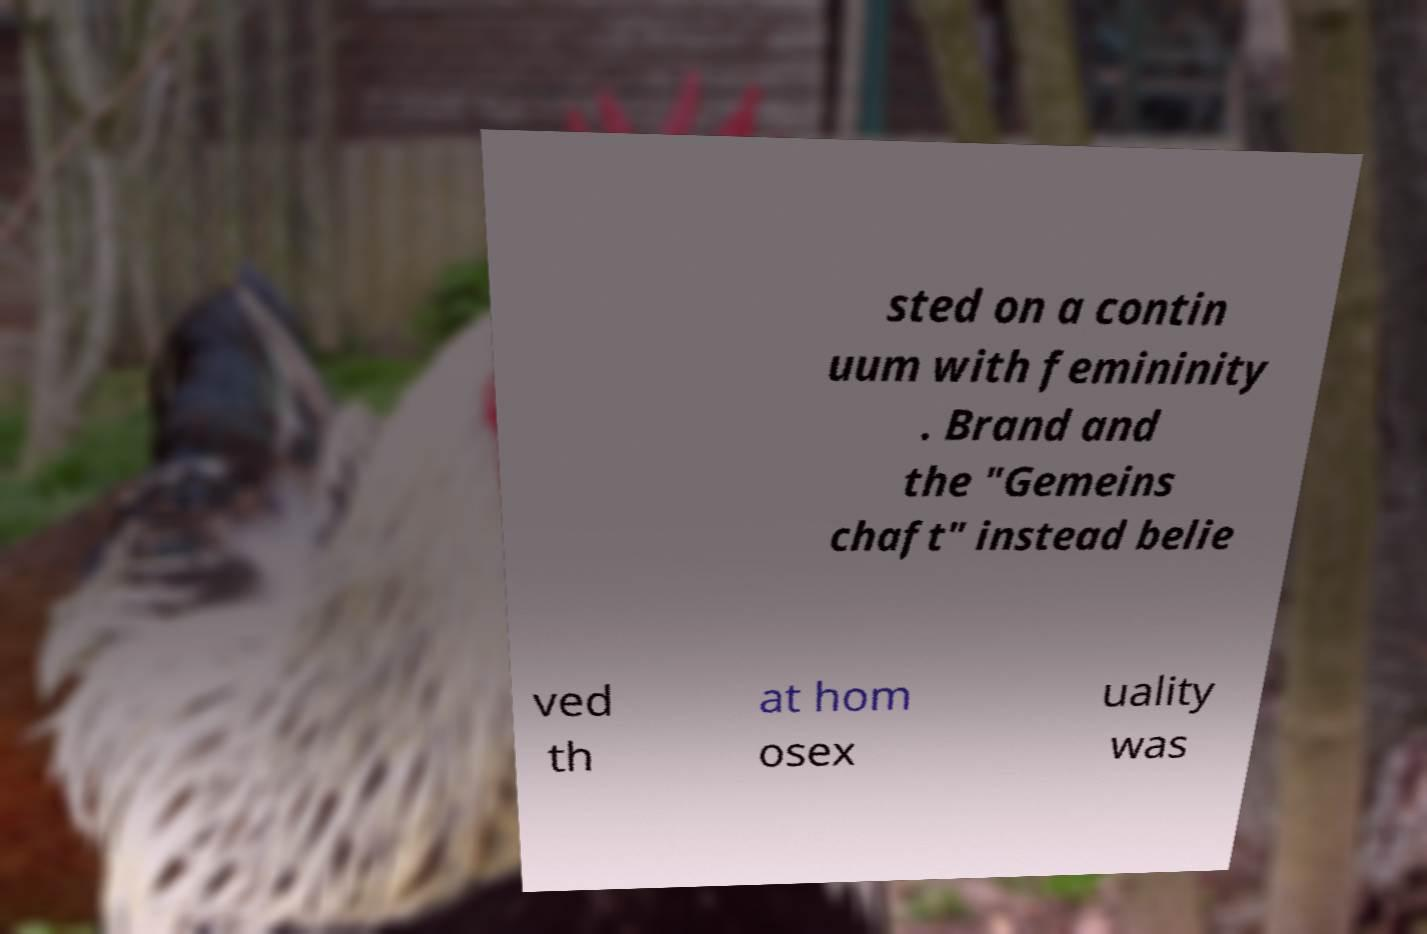I need the written content from this picture converted into text. Can you do that? sted on a contin uum with femininity . Brand and the "Gemeins chaft" instead belie ved th at hom osex uality was 